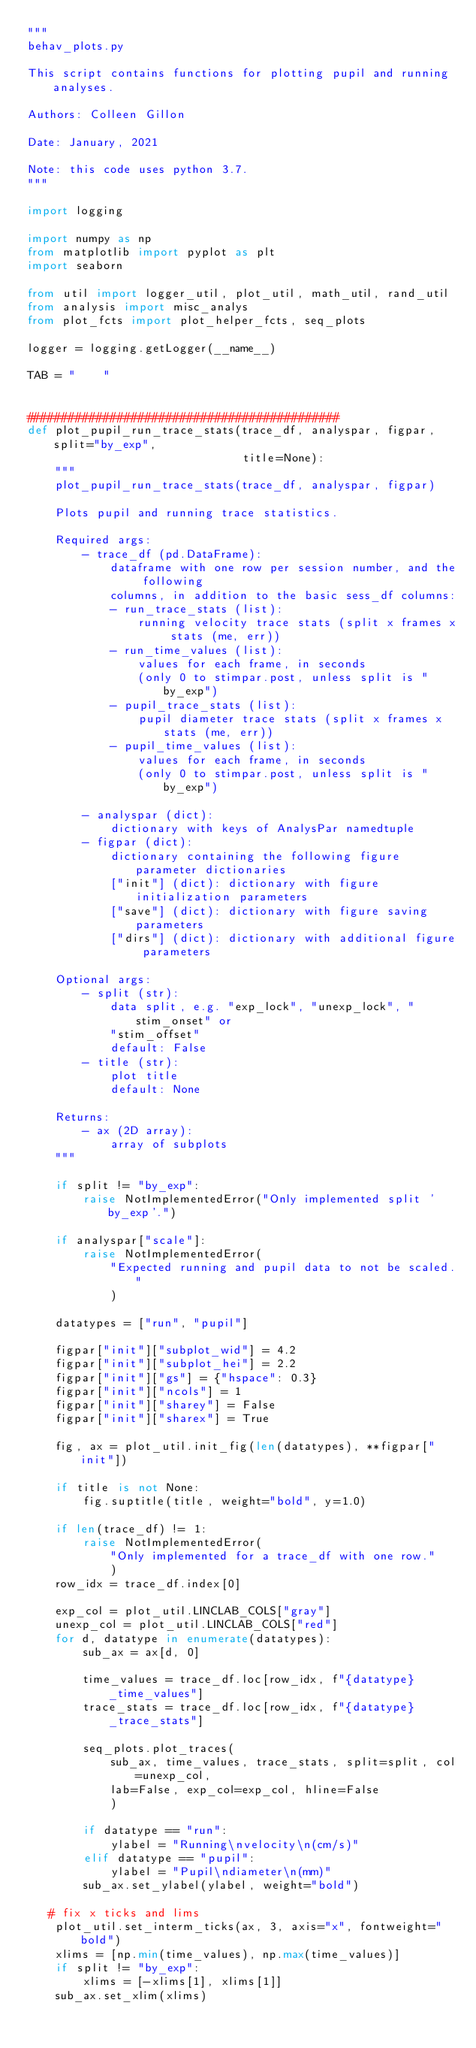<code> <loc_0><loc_0><loc_500><loc_500><_Python_>"""
behav_plots.py

This script contains functions for plotting pupil and running analyses.

Authors: Colleen Gillon

Date: January, 2021

Note: this code uses python 3.7.
"""

import logging

import numpy as np
from matplotlib import pyplot as plt
import seaborn

from util import logger_util, plot_util, math_util, rand_util
from analysis import misc_analys
from plot_fcts import plot_helper_fcts, seq_plots

logger = logging.getLogger(__name__)

TAB = "    "


#############################################
def plot_pupil_run_trace_stats(trace_df, analyspar, figpar, split="by_exp", 
                               title=None):
    """
    plot_pupil_run_trace_stats(trace_df, analyspar, figpar)

    Plots pupil and running trace statistics.

    Required args:
        - trace_df (pd.DataFrame):
            dataframe with one row per session number, and the following 
            columns, in addition to the basic sess_df columns: 
            - run_trace_stats (list): 
                running velocity trace stats (split x frames x stats (me, err))
            - run_time_values (list):
                values for each frame, in seconds
                (only 0 to stimpar.post, unless split is "by_exp")
            - pupil_trace_stats (list): 
                pupil diameter trace stats (split x frames x stats (me, err))
            - pupil_time_values (list):
                values for each frame, in seconds
                (only 0 to stimpar.post, unless split is "by_exp")    

        - analyspar (dict): 
            dictionary with keys of AnalysPar namedtuple
        - figpar (dict): 
            dictionary containing the following figure parameter dictionaries
            ["init"] (dict): dictionary with figure initialization parameters
            ["save"] (dict): dictionary with figure saving parameters
            ["dirs"] (dict): dictionary with additional figure parameters

    Optional args:
        - split (str):
            data split, e.g. "exp_lock", "unexp_lock", "stim_onset" or 
            "stim_offset"
            default: False
        - title (str):
            plot title
            default: None

    Returns:
        - ax (2D array): 
            array of subplots
    """

    if split != "by_exp":
        raise NotImplementedError("Only implemented split 'by_exp'.")

    if analyspar["scale"]:
        raise NotImplementedError(
            "Expected running and pupil data to not be scaled."
            )

    datatypes = ["run", "pupil"]

    figpar["init"]["subplot_wid"] = 4.2
    figpar["init"]["subplot_hei"] = 2.2
    figpar["init"]["gs"] = {"hspace": 0.3}
    figpar["init"]["ncols"] = 1
    figpar["init"]["sharey"] = False
    figpar["init"]["sharex"] = True

    fig, ax = plot_util.init_fig(len(datatypes), **figpar["init"])

    if title is not None:
        fig.suptitle(title, weight="bold", y=1.0)

    if len(trace_df) != 1:
        raise NotImplementedError(
            "Only implemented for a trace_df with one row."
            )
    row_idx = trace_df.index[0]

    exp_col = plot_util.LINCLAB_COLS["gray"]
    unexp_col = plot_util.LINCLAB_COLS["red"]
    for d, datatype in enumerate(datatypes):
        sub_ax = ax[d, 0]

        time_values = trace_df.loc[row_idx, f"{datatype}_time_values"]
        trace_stats = trace_df.loc[row_idx, f"{datatype}_trace_stats"]

        seq_plots.plot_traces(
            sub_ax, time_values, trace_stats, split=split, col=unexp_col, 
            lab=False, exp_col=exp_col, hline=False
            )
    
        if datatype == "run":
            ylabel = "Running\nvelocity\n(cm/s)"
        elif datatype == "pupil":
            ylabel = "Pupil\ndiameter\n(mm)"
        sub_ax.set_ylabel(ylabel, weight="bold")

   # fix x ticks and lims
    plot_util.set_interm_ticks(ax, 3, axis="x", fontweight="bold")
    xlims = [np.min(time_values), np.max(time_values)]
    if split != "by_exp":
        xlims = [-xlims[1], xlims[1]]
    sub_ax.set_xlim(xlims)</code> 